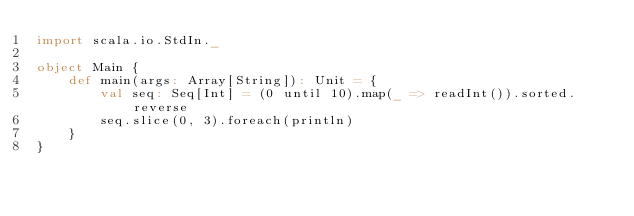Convert code to text. <code><loc_0><loc_0><loc_500><loc_500><_Scala_>import scala.io.StdIn._
 
object Main {
    def main(args: Array[String]): Unit = { 
        val seq: Seq[Int] = (0 until 10).map(_ => readInt()).sorted.reverse
        seq.slice(0, 3).foreach(println)
    }   
}</code> 